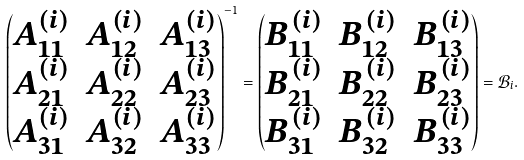<formula> <loc_0><loc_0><loc_500><loc_500>\begin{pmatrix} A _ { 1 1 } ^ { ( i ) } & A _ { 1 2 } ^ { ( i ) } & A _ { 1 3 } ^ { ( i ) } \\ A _ { 2 1 } ^ { ( i ) } & A _ { 2 2 } ^ { ( i ) } & A _ { 2 3 } ^ { ( i ) } \\ A _ { 3 1 } ^ { ( i ) } & A _ { 3 2 } ^ { ( i ) } & A _ { 3 3 } ^ { ( i ) } \end{pmatrix} ^ { - 1 } = \begin{pmatrix} B _ { 1 1 } ^ { ( i ) } & B _ { 1 2 } ^ { ( i ) } & B _ { 1 3 } ^ { ( i ) } \\ B _ { 2 1 } ^ { ( i ) } & B _ { 2 2 } ^ { ( i ) } & B _ { 2 3 } ^ { ( i ) } \\ B _ { 3 1 } ^ { ( i ) } & B _ { 3 2 } ^ { ( i ) } & B _ { 3 3 } ^ { ( i ) } \end{pmatrix} = \mathcal { B } _ { i } .</formula> 